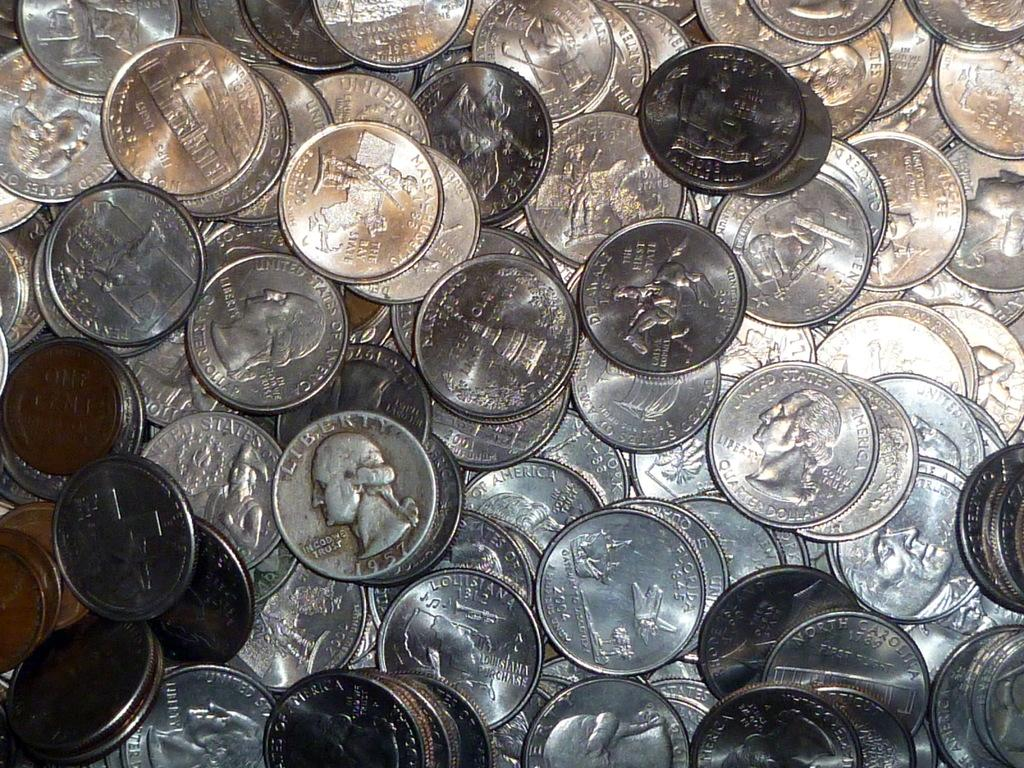What type of objects are present in the image? There are currency coins in the image. Can you describe the appearance of the objects? The objects are small, round, and typically made of metal or plastic, with various designs and values printed on them. What might these objects be used for? Currency coins are used as a medium of exchange for goods and services, and their value is determined by the issuing authority. What type of boundary is depicted in the image? There is no boundary present in the image; it only contains currency coins. Can you tell me the account balance of the person who owns these coins? The image does not provide information about the account balance of the person who owns these coins. 